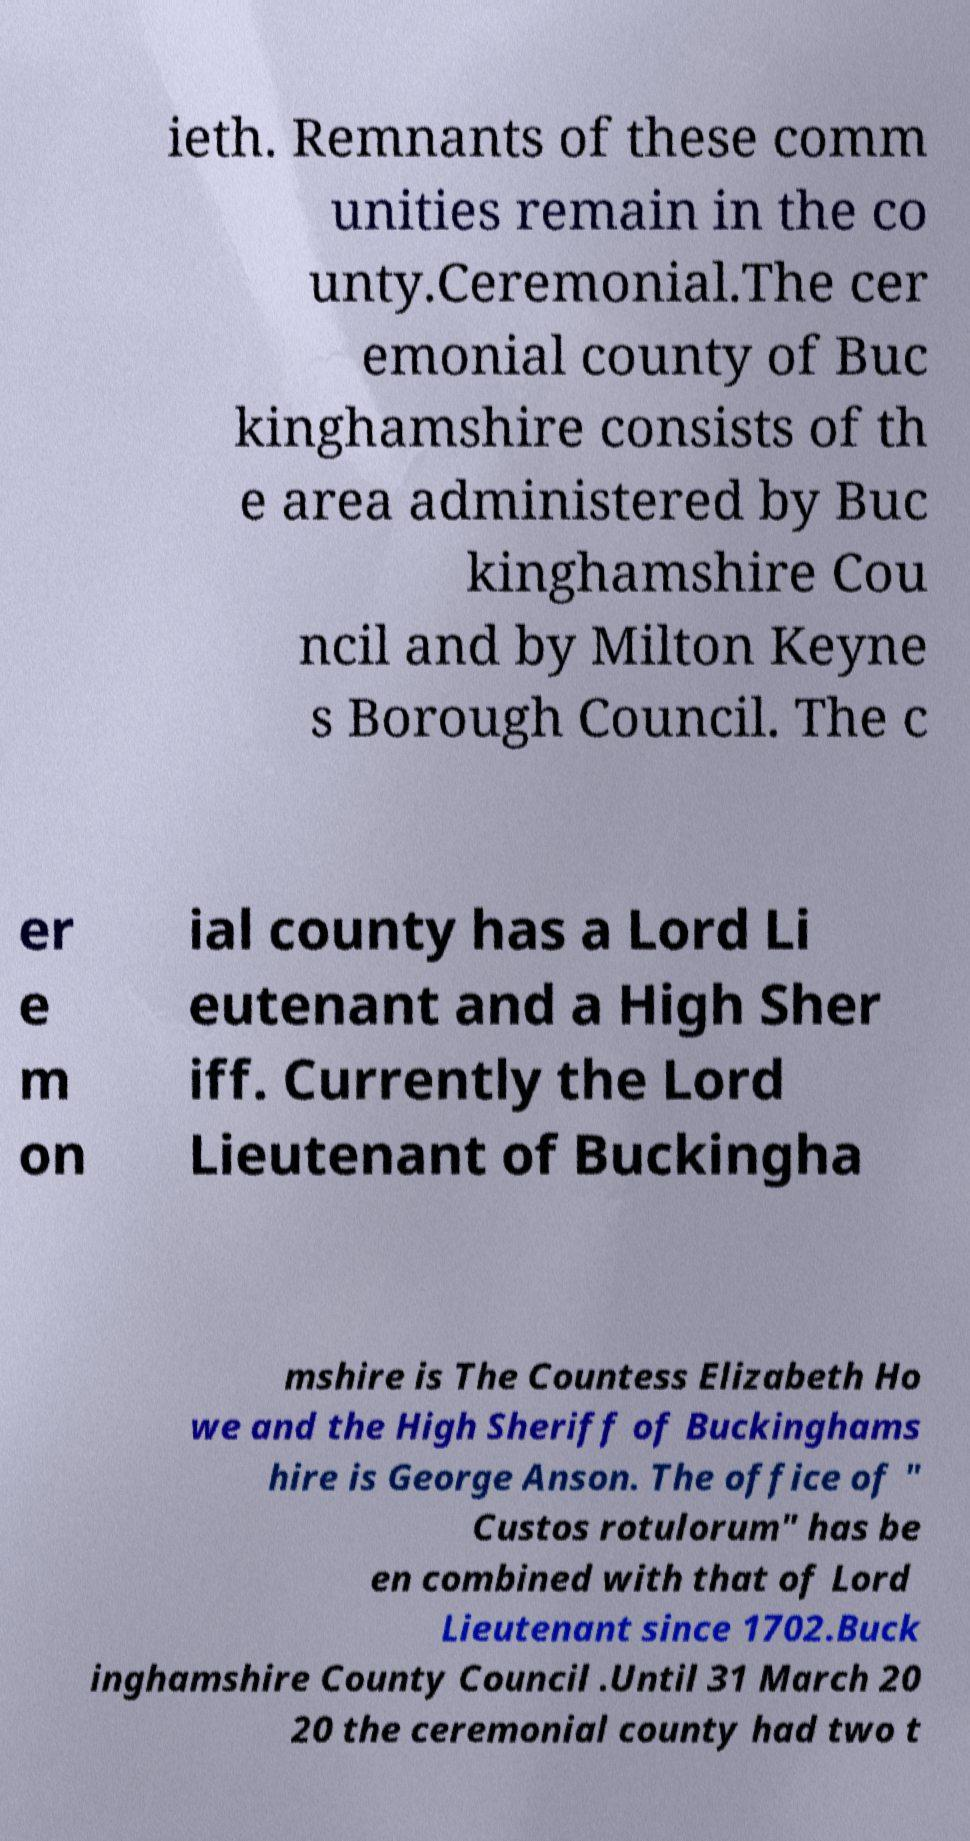There's text embedded in this image that I need extracted. Can you transcribe it verbatim? ieth. Remnants of these comm unities remain in the co unty.Ceremonial.The cer emonial county of Buc kinghamshire consists of th e area administered by Buc kinghamshire Cou ncil and by Milton Keyne s Borough Council. The c er e m on ial county has a Lord Li eutenant and a High Sher iff. Currently the Lord Lieutenant of Buckingha mshire is The Countess Elizabeth Ho we and the High Sheriff of Buckinghams hire is George Anson. The office of " Custos rotulorum" has be en combined with that of Lord Lieutenant since 1702.Buck inghamshire County Council .Until 31 March 20 20 the ceremonial county had two t 